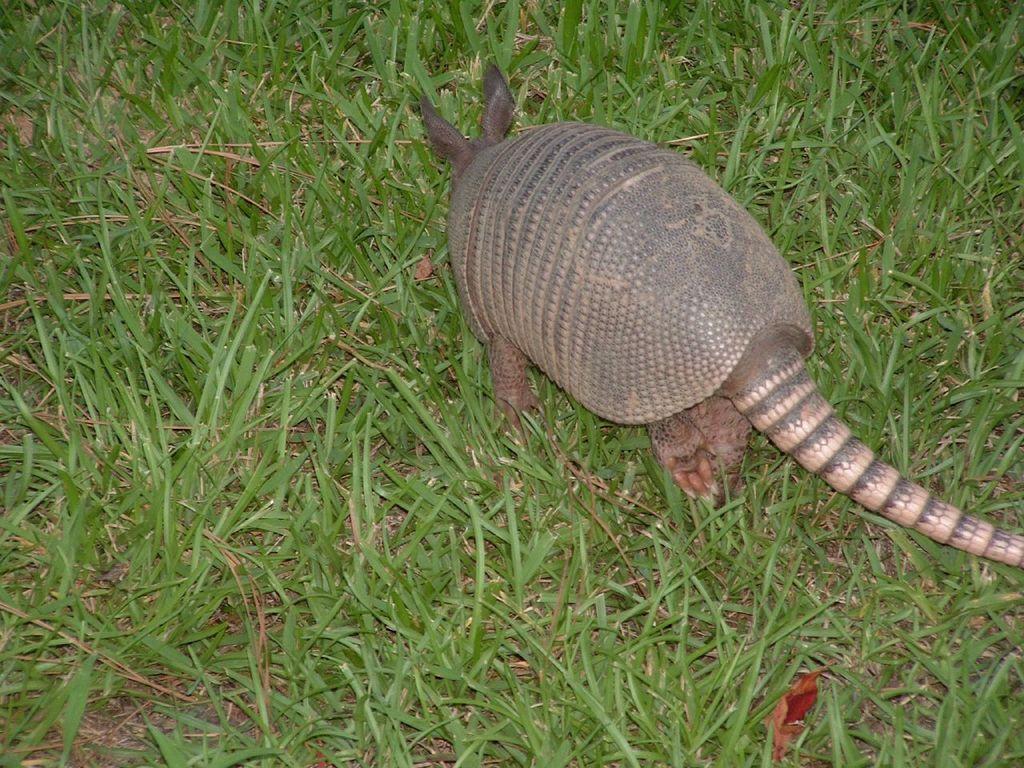Could you give a brief overview of what you see in this image? In this image, we can see an animal walking on the grass. 